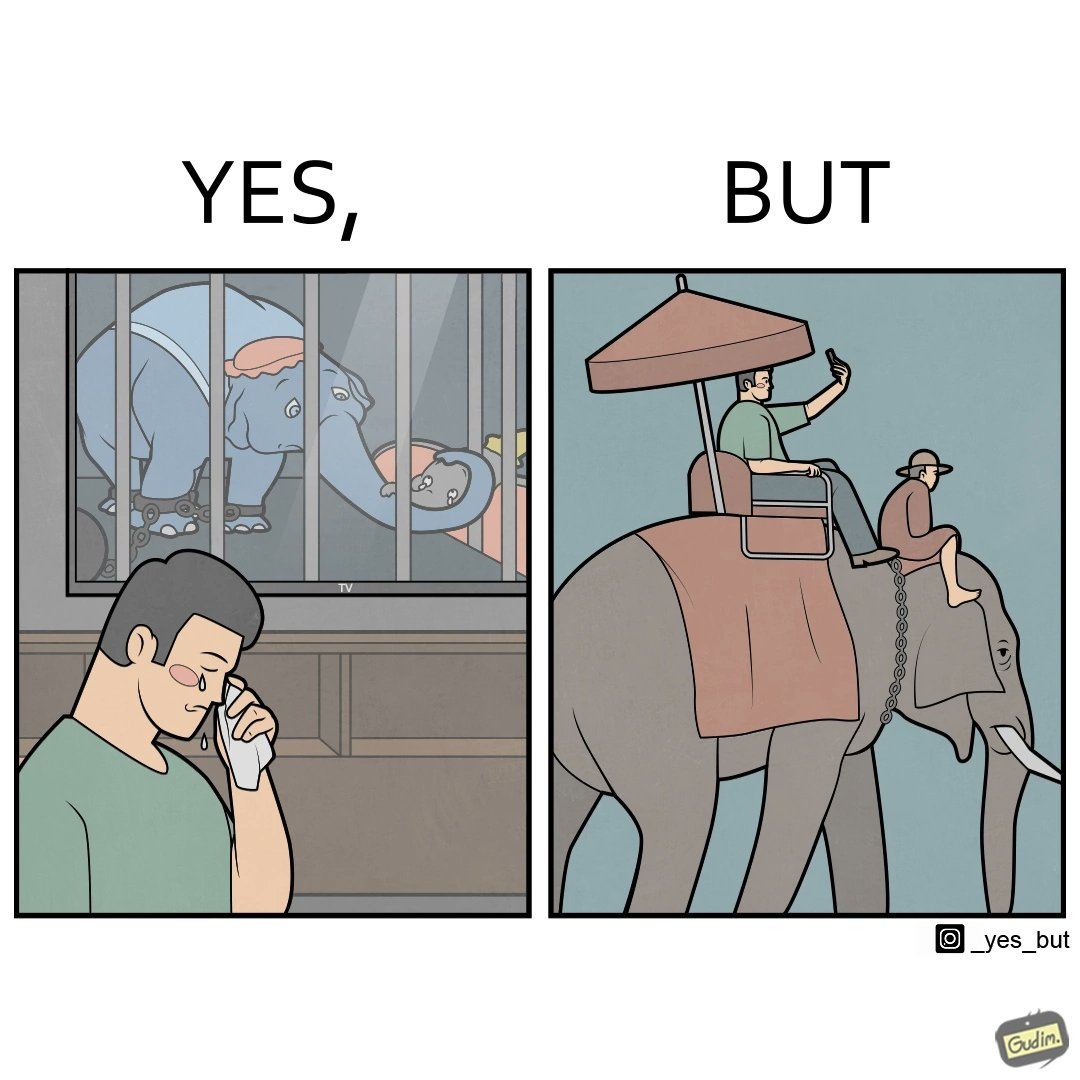Compare the left and right sides of this image. In the left part of the image: a man crying on seeing an elephant being chained in a cage in a TV program In the right part of the image: a person riding an elephant while taking selfies 